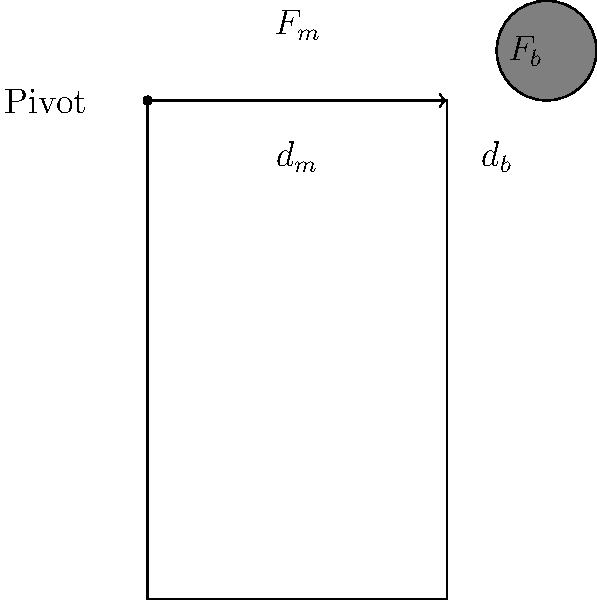In the leg-football system shown above, the leg acts as a lever with the hip joint as the pivot. The muscle force $F_m$ is applied at a distance $d_m = 0.3$ m from the pivot, while the ball is struck at a distance $d_b = 0.8$ m from the pivot. If the muscle force $F_m = 2000$ N, what is the magnitude of the force $F_b$ applied to the football? To solve this problem, we'll use the principle of moments for a lever system:

1) In equilibrium, the sum of moments about the pivot point is zero.

2) The moment is calculated as force multiplied by perpendicular distance from the pivot.

3) We can write the equation:
   $F_m \cdot d_m = F_b \cdot d_b$

4) Substituting the known values:
   $2000 \text{ N} \cdot 0.3 \text{ m} = F_b \cdot 0.8 \text{ m}$

5) Simplify the left side:
   $600 \text{ N}\cdot\text{m} = F_b \cdot 0.8 \text{ m}$

6) Solve for $F_b$:
   $F_b = \frac{600 \text{ N}\cdot\text{m}}{0.8 \text{ m}} = 750 \text{ N}$

Therefore, the force applied to the football is 750 N.
Answer: 750 N 